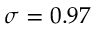<formula> <loc_0><loc_0><loc_500><loc_500>\sigma = 0 . 9 7</formula> 